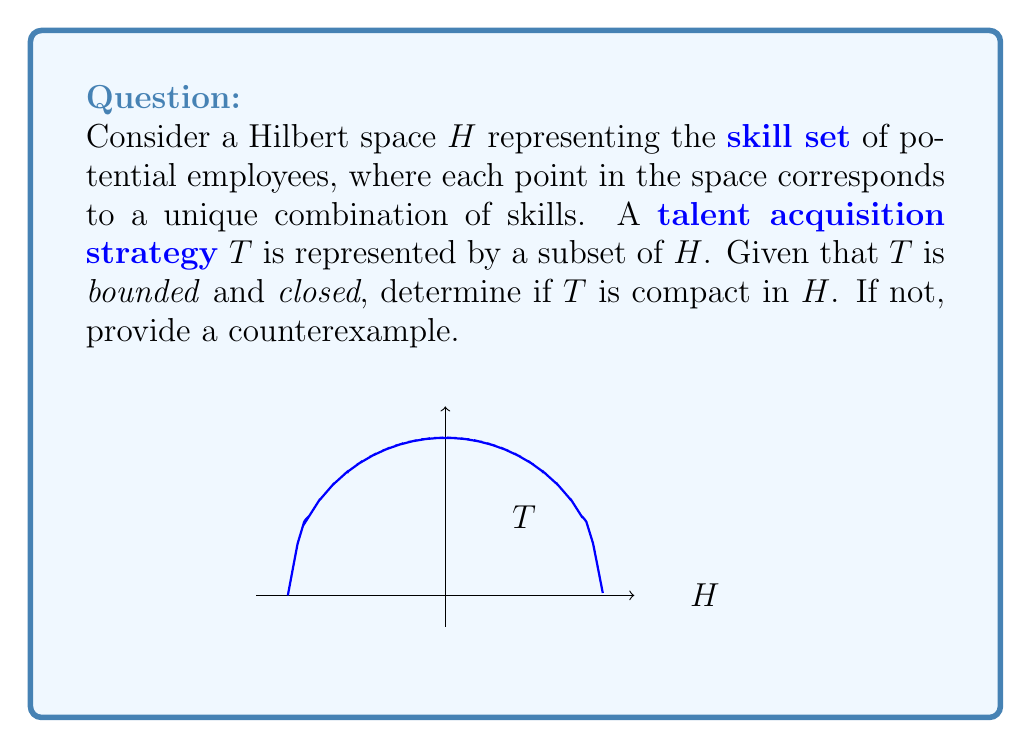Could you help me with this problem? To determine if $T$ is compact in the Hilbert space $H$, we need to consider the following steps:

1) In a Hilbert space, a subset is compact if and only if it is closed and bounded.

2) We are given that $T$ is bounded and closed. However, this is not sufficient to conclude that $T$ is compact in $H$.

3) In infinite-dimensional Hilbert spaces, closed and bounded sets are not necessarily compact. This is a key difference from finite-dimensional spaces.

4) The Hilbert space $H$ representing the skill set of potential employees is likely infinite-dimensional, as there can be an infinite number of possible skills or skill combinations.

5) In infinite-dimensional Hilbert spaces, a set is compact if and only if it is closed, bounded, and totally bounded (i.e., for every $\epsilon > 0$, the set can be covered by a finite number of balls of radius $\epsilon$).

6) A classic counterexample in infinite-dimensional Hilbert spaces is the closed unit ball:
   $$B = \{x \in H : \|x\| \leq 1\}$$
   This set is closed and bounded but not compact in infinite dimensions.

7) In the context of talent acquisition, $T$ could represent a strategy that considers all skill combinations within a certain "norm" or threshold. This would be analogous to the closed unit ball in $H$.

Therefore, without additional information about the total boundedness of $T$, we cannot conclude that it is compact. In fact, if $H$ is infinite-dimensional, $T$ is likely not compact.
Answer: $T$ is not necessarily compact. A counterexample is the closed unit ball in an infinite-dimensional Hilbert space. 